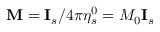<formula> <loc_0><loc_0><loc_500><loc_500>M = I _ { s } / 4 \pi \eta _ { s } ^ { 0 } = M _ { 0 } I _ { s }</formula> 